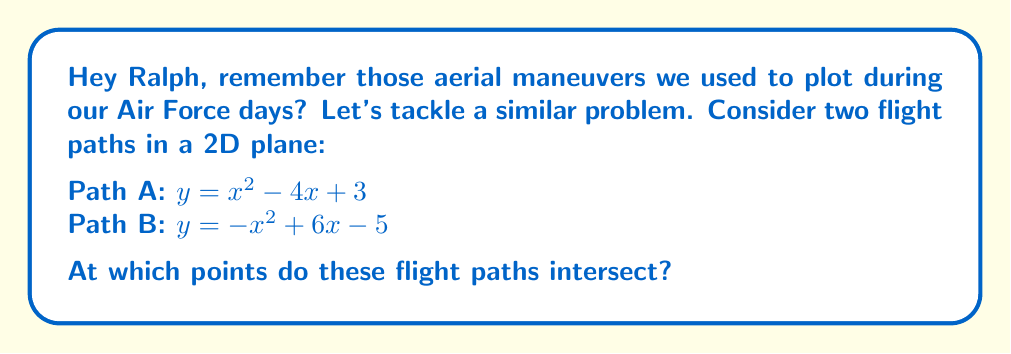Can you answer this question? Let's approach this step-by-step, Ralph:

1) To find the intersection points, we need to solve the equation:
   $x^2 - 4x + 3 = -x^2 + 6x - 5$

2) Let's rearrange the equation:
   $x^2 - 4x + 3 + x^2 - 6x + 5 = 0$

3) Simplify:
   $2x^2 - 10x + 8 = 0$

4) Divide everything by 2:
   $x^2 - 5x + 4 = 0$

5) This is a quadratic equation. We can solve it using the quadratic formula:
   $x = \frac{-b \pm \sqrt{b^2 - 4ac}}{2a}$

   Where $a=1$, $b=-5$, and $c=4$

6) Plugging in these values:
   $x = \frac{5 \pm \sqrt{25 - 16}}{2} = \frac{5 \pm 3}{2}$

7) This gives us two solutions:
   $x_1 = \frac{5 + 3}{2} = 4$ and $x_2 = \frac{5 - 3}{2} = 1$

8) To find the y-coordinates, we can plug these x-values into either of the original equations. Let's use the first one:

   For $x_1 = 4$: $y = 4^2 - 4(4) + 3 = 16 - 16 + 3 = 3$
   For $x_2 = 1$: $y = 1^2 - 4(1) + 3 = 1 - 4 + 3 = 0$

Therefore, the intersection points are (4, 3) and (1, 0).
Answer: (4, 3) and (1, 0) 